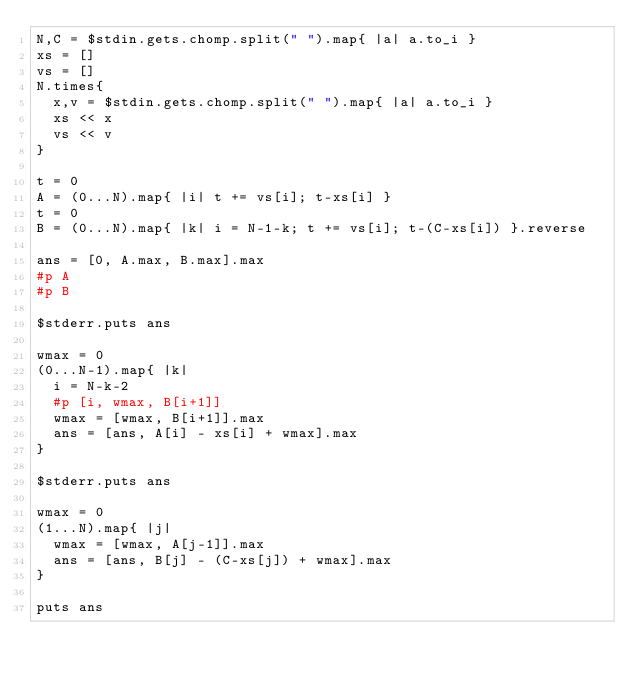Convert code to text. <code><loc_0><loc_0><loc_500><loc_500><_Ruby_>N,C = $stdin.gets.chomp.split(" ").map{ |a| a.to_i }
xs = []
vs = []
N.times{
  x,v = $stdin.gets.chomp.split(" ").map{ |a| a.to_i }
  xs << x
  vs << v
}

t = 0
A = (0...N).map{ |i| t += vs[i]; t-xs[i] }
t = 0
B = (0...N).map{ |k| i = N-1-k; t += vs[i]; t-(C-xs[i]) }.reverse

ans = [0, A.max, B.max].max
#p A
#p B

$stderr.puts ans

wmax = 0
(0...N-1).map{ |k|
  i = N-k-2
  #p [i, wmax, B[i+1]]
  wmax = [wmax, B[i+1]].max
  ans = [ans, A[i] - xs[i] + wmax].max
}

$stderr.puts ans

wmax = 0
(1...N).map{ |j|
  wmax = [wmax, A[j-1]].max
  ans = [ans, B[j] - (C-xs[j]) + wmax].max
}

puts ans
</code> 